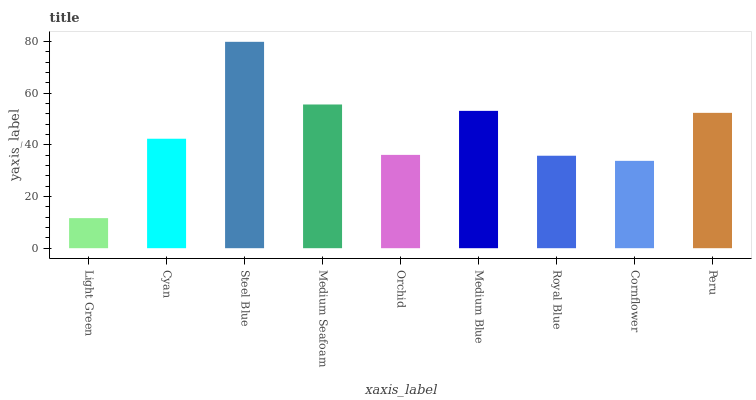Is Cyan the minimum?
Answer yes or no. No. Is Cyan the maximum?
Answer yes or no. No. Is Cyan greater than Light Green?
Answer yes or no. Yes. Is Light Green less than Cyan?
Answer yes or no. Yes. Is Light Green greater than Cyan?
Answer yes or no. No. Is Cyan less than Light Green?
Answer yes or no. No. Is Cyan the high median?
Answer yes or no. Yes. Is Cyan the low median?
Answer yes or no. Yes. Is Orchid the high median?
Answer yes or no. No. Is Cornflower the low median?
Answer yes or no. No. 